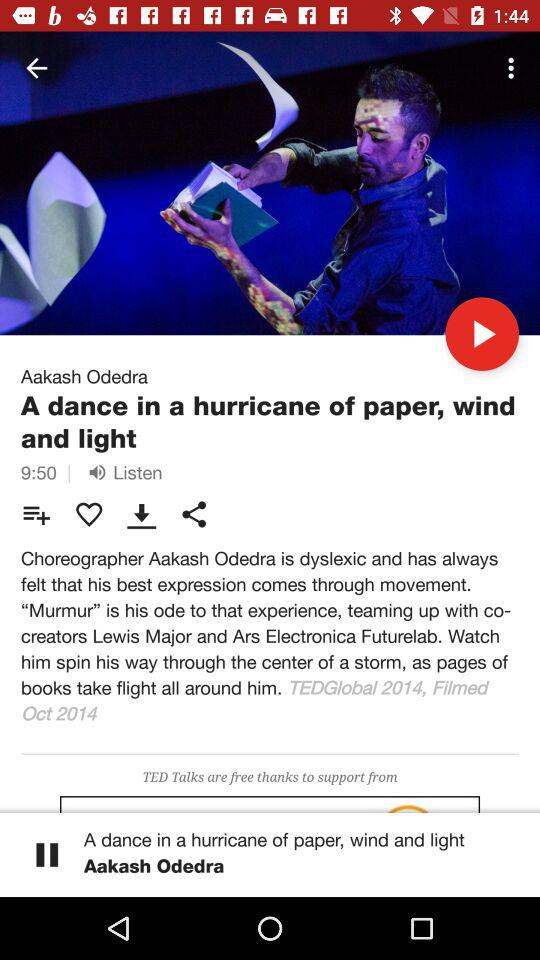What is the speaker name? The speaker name is Aakash Odedra. 